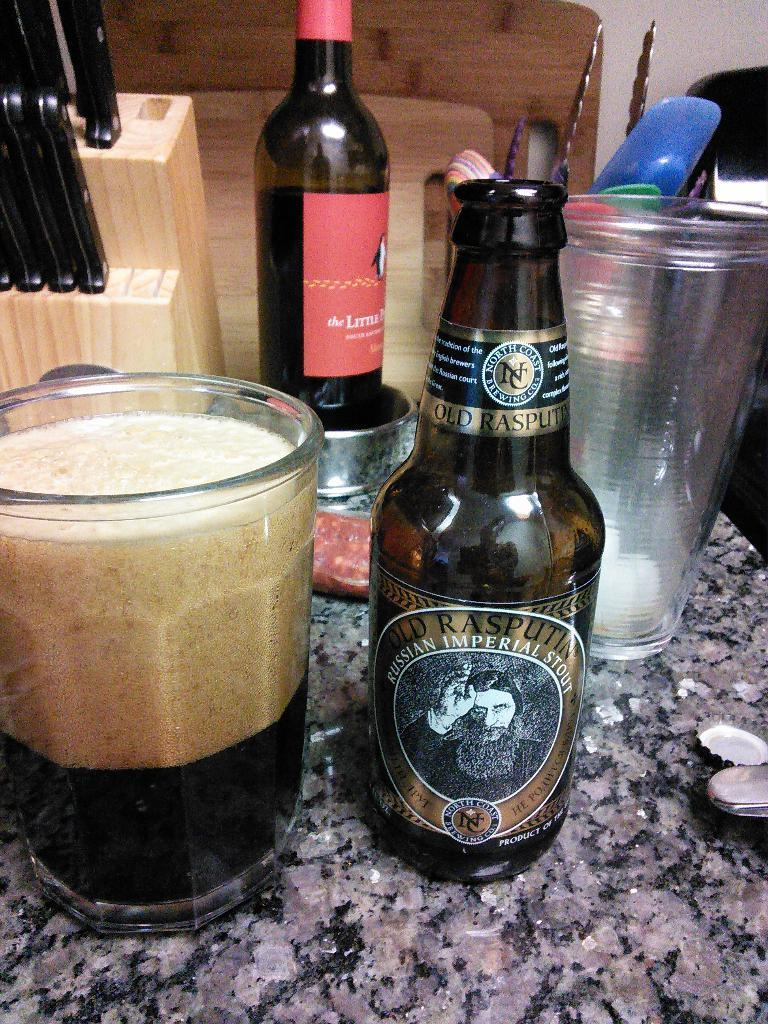<image>
Create a compact narrative representing the image presented. An empty bottle of Russian Imperial Stout with a glass full of liquid next to it. 